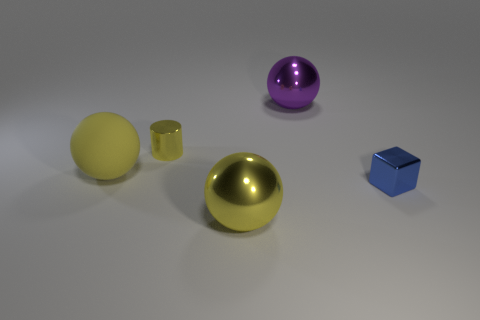Add 5 large blue metal cubes. How many objects exist? 10 Subtract all cubes. How many objects are left? 4 Subtract all green shiny spheres. Subtract all blue things. How many objects are left? 4 Add 1 small blue shiny objects. How many small blue shiny objects are left? 2 Add 2 tiny blue metal objects. How many tiny blue metal objects exist? 3 Subtract 0 green cubes. How many objects are left? 5 